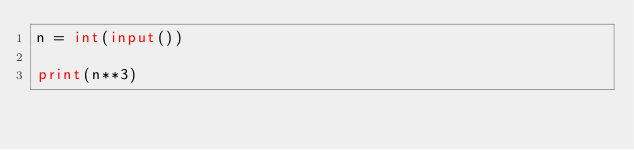Convert code to text. <code><loc_0><loc_0><loc_500><loc_500><_Python_>n = int(input())

print(n**3)</code> 